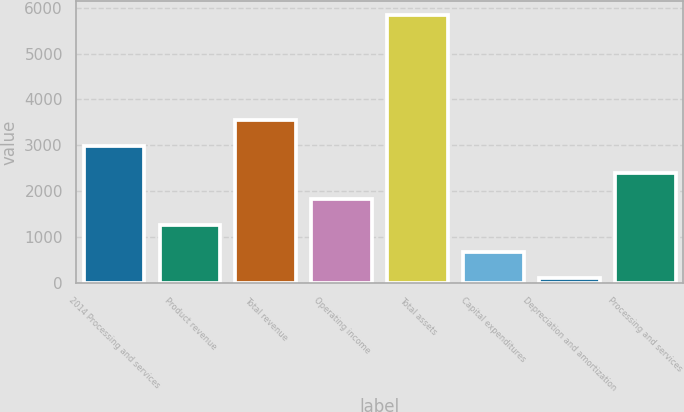Convert chart to OTSL. <chart><loc_0><loc_0><loc_500><loc_500><bar_chart><fcel>2014 Processing and services<fcel>Product revenue<fcel>Total revenue<fcel>Operating income<fcel>Total assets<fcel>Capital expenditures<fcel>Depreciation and amortization<fcel>Processing and services<nl><fcel>2976<fcel>1251.6<fcel>3550.8<fcel>1826.4<fcel>5850<fcel>676.8<fcel>102<fcel>2401.2<nl></chart> 